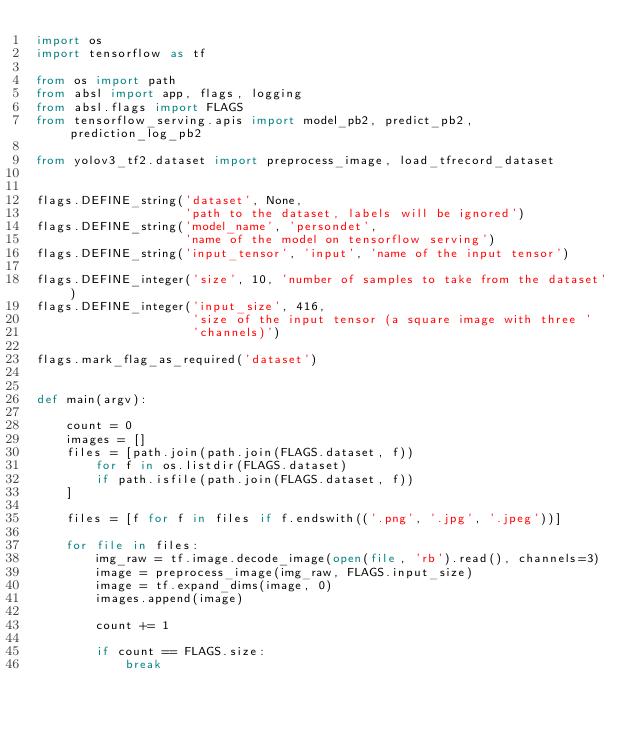<code> <loc_0><loc_0><loc_500><loc_500><_Python_>import os
import tensorflow as tf

from os import path
from absl import app, flags, logging
from absl.flags import FLAGS
from tensorflow_serving.apis import model_pb2, predict_pb2, prediction_log_pb2

from yolov3_tf2.dataset import preprocess_image, load_tfrecord_dataset


flags.DEFINE_string('dataset', None,
                    'path to the dataset, labels will be ignored')
flags.DEFINE_string('model_name', 'persondet',
                    'name of the model on tensorflow serving')
flags.DEFINE_string('input_tensor', 'input', 'name of the input tensor')

flags.DEFINE_integer('size', 10, 'number of samples to take from the dataset')
flags.DEFINE_integer('input_size', 416,
                     'size of the input tensor (a square image with three '
                     'channels)')

flags.mark_flag_as_required('dataset')


def main(argv):

    count = 0
    images = []
    files = [path.join(path.join(FLAGS.dataset, f))
        for f in os.listdir(FLAGS.dataset)
        if path.isfile(path.join(FLAGS.dataset, f))
    ]

    files = [f for f in files if f.endswith(('.png', '.jpg', '.jpeg'))]

    for file in files:
        img_raw = tf.image.decode_image(open(file, 'rb').read(), channels=3)
        image = preprocess_image(img_raw, FLAGS.input_size)
        image = tf.expand_dims(image, 0)
        images.append(image)

        count += 1

        if count == FLAGS.size:
            break
</code> 